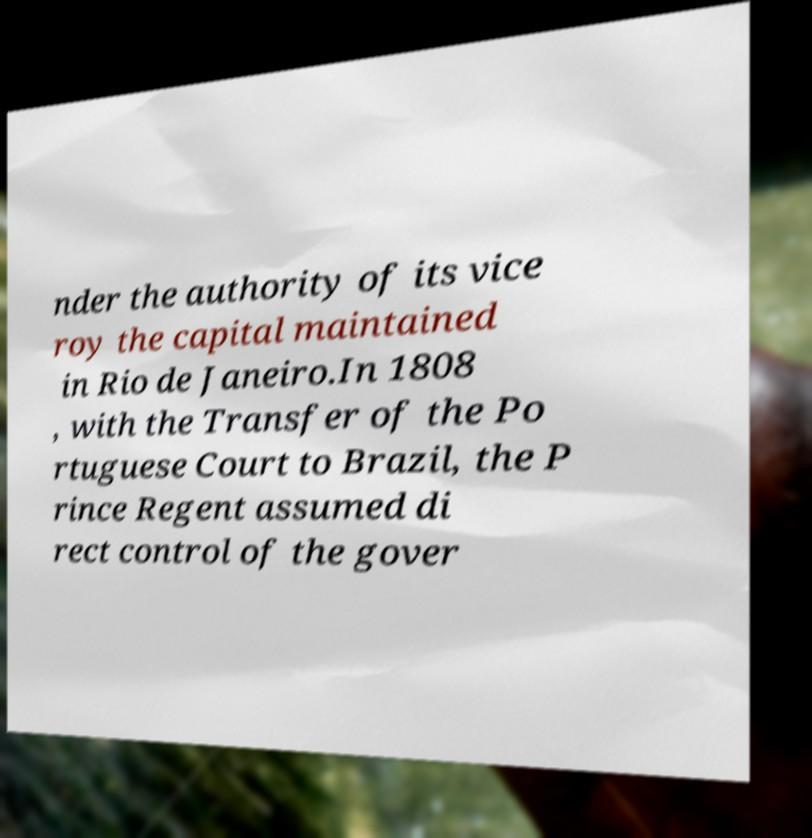Please read and relay the text visible in this image. What does it say? nder the authority of its vice roy the capital maintained in Rio de Janeiro.In 1808 , with the Transfer of the Po rtuguese Court to Brazil, the P rince Regent assumed di rect control of the gover 